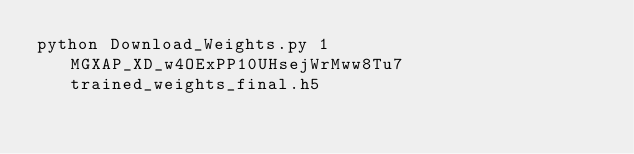Convert code to text. <code><loc_0><loc_0><loc_500><loc_500><_Bash_>python Download_Weights.py 1MGXAP_XD_w4OExPP10UHsejWrMww8Tu7 trained_weights_final.h5
</code> 